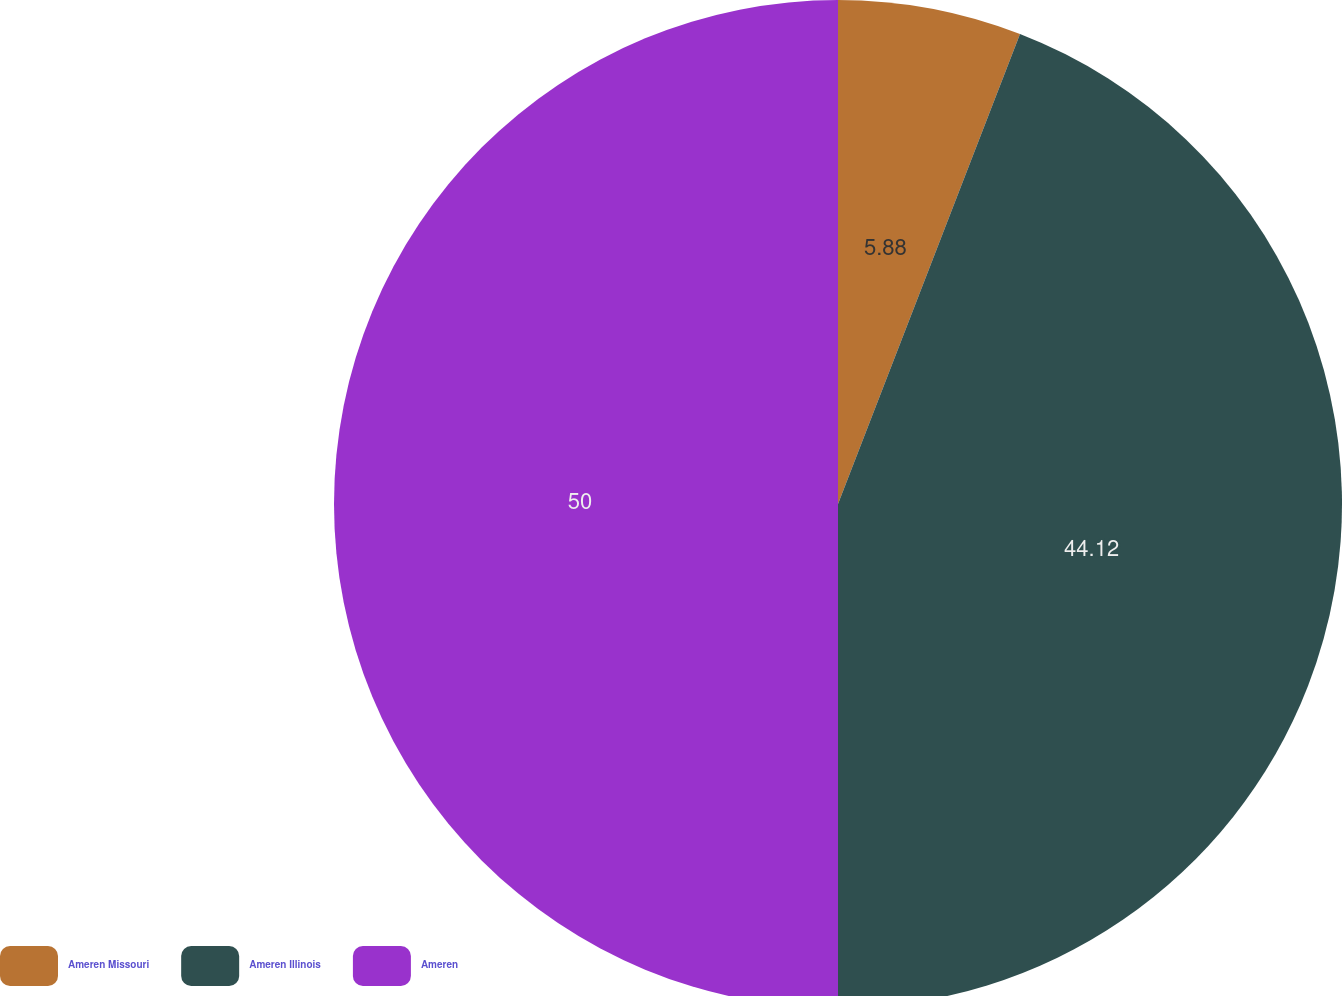<chart> <loc_0><loc_0><loc_500><loc_500><pie_chart><fcel>Ameren Missouri<fcel>Ameren Illinois<fcel>Ameren<nl><fcel>5.88%<fcel>44.12%<fcel>50.0%<nl></chart> 